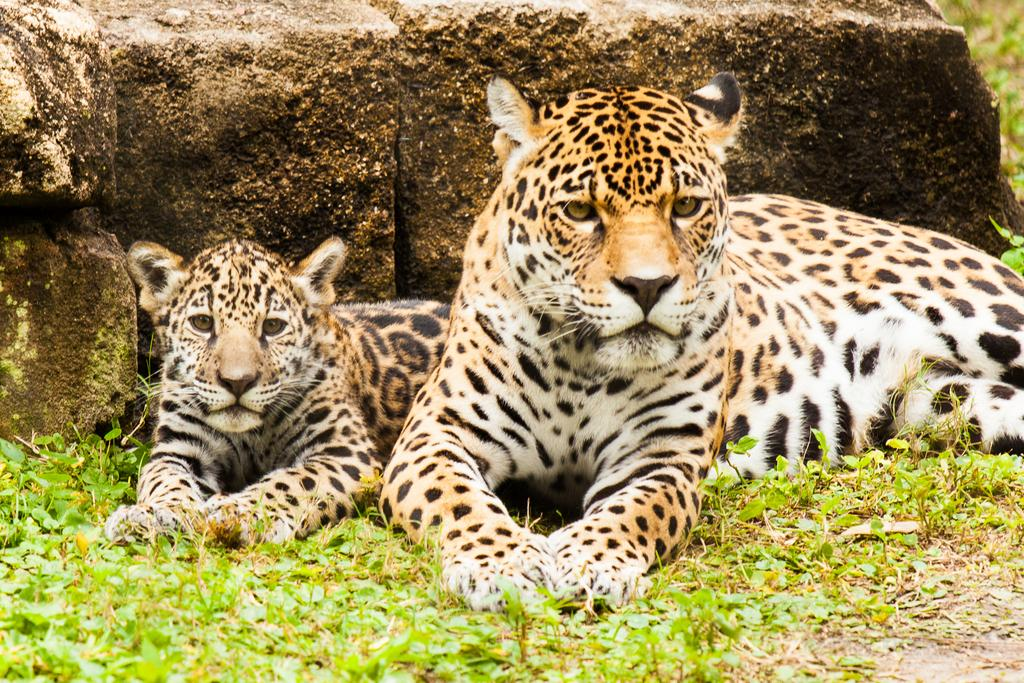What type of animals can be seen in the image? There are animals on the ground in the image. What type of vegetation is visible in the image? There is grass visible in the image. What can be seen in the background of the image? There are rocks in the background of the image. How can the animals be helped to find the hidden amusement in the image? There is no amusement present in the image, and the animals do not need help finding something that is not there. 